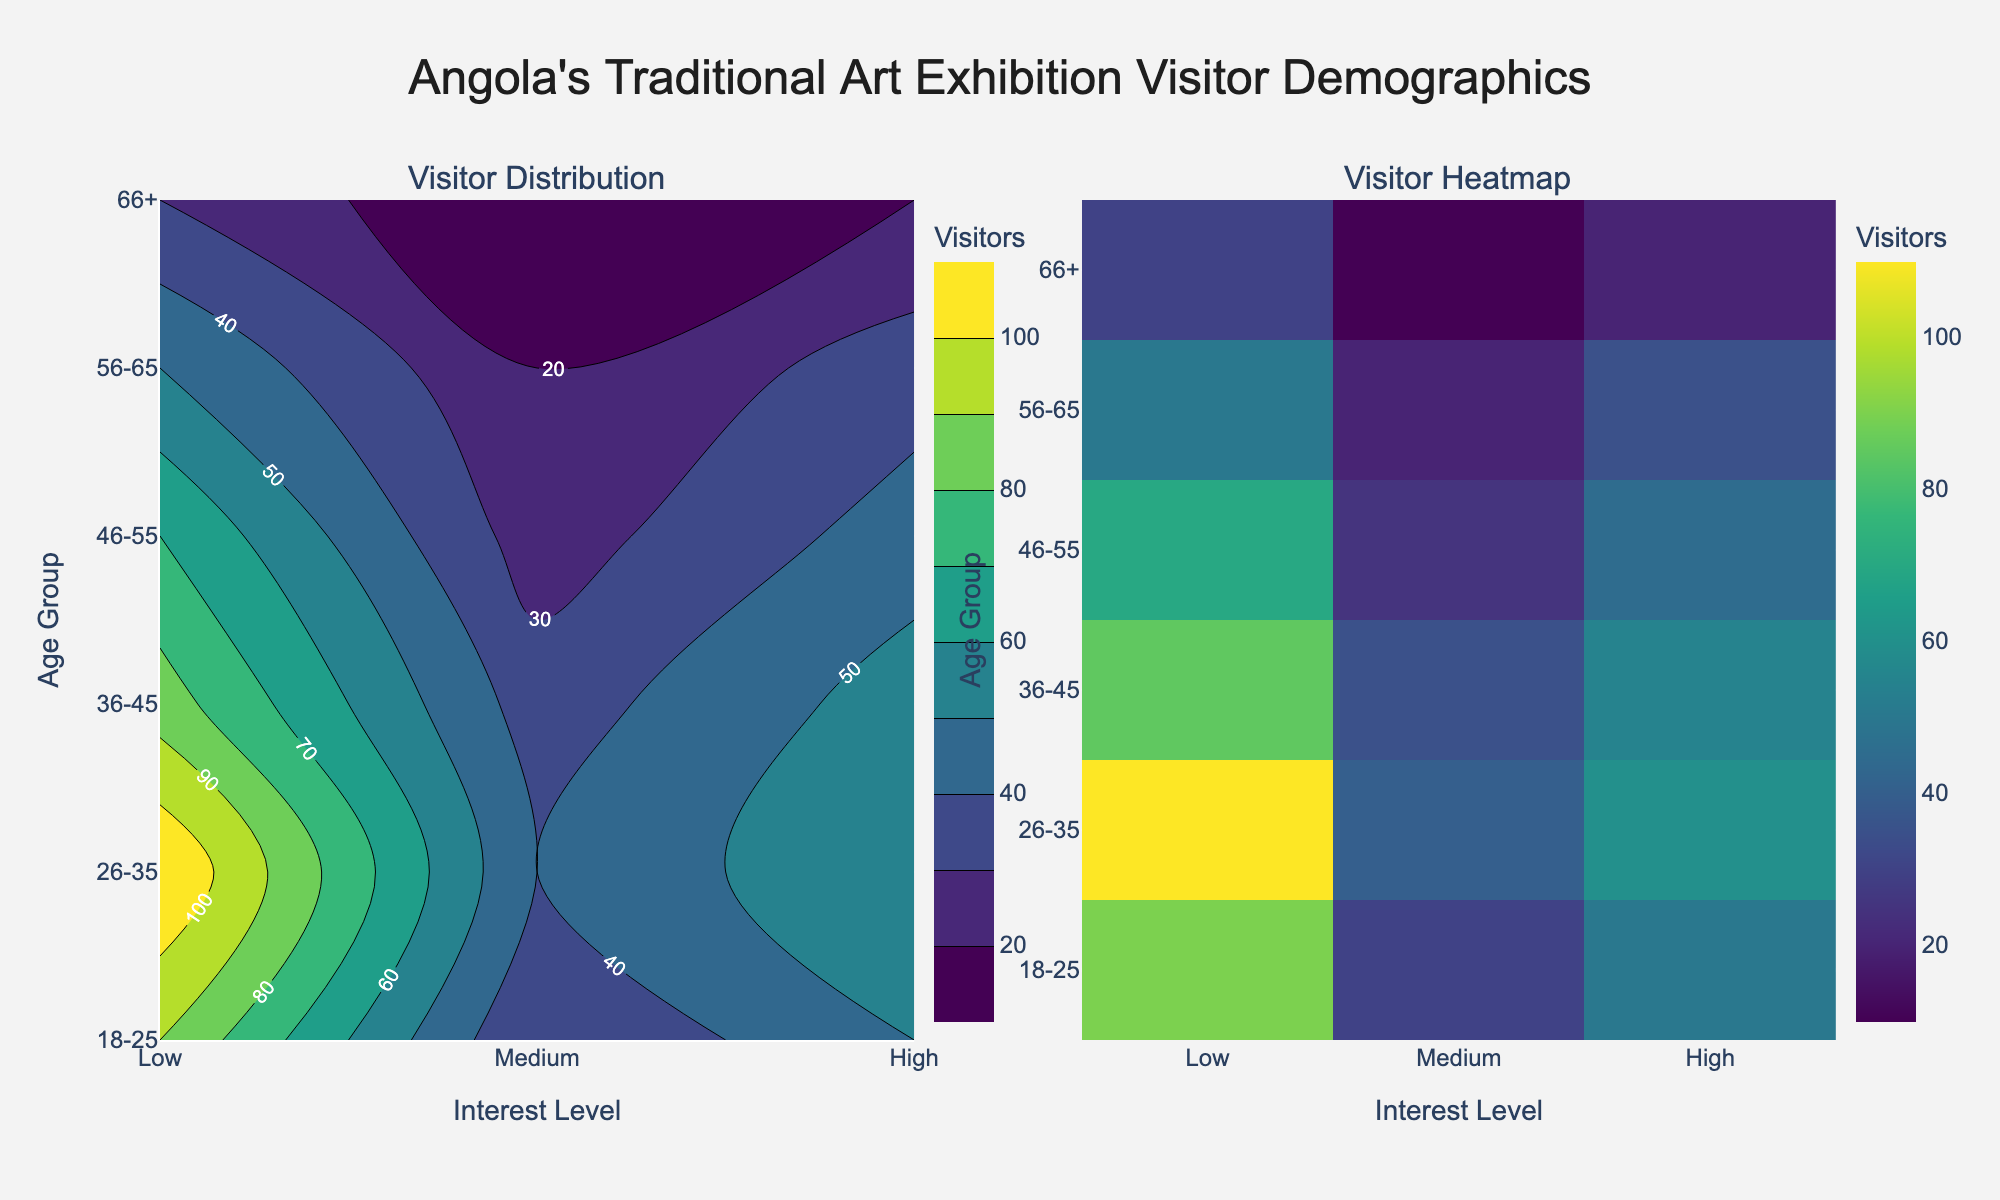What's the title of the plot? The plot title is usually located at the top center of the figure. In this case, we look at the top to find the text describing the main focus, which reads "Angola's Traditional Art Exhibition Visitor Demographics".
Answer: Angola's Traditional Art Exhibition Visitor Demographics What are the two main visualization types used in the figure? The figure is divided into two sections, each using a different type of plot. The left section is a contour plot, and the right section is a heatmap.
Answer: Contour plot and heatmap Which age group has the highest number of visitors with "High" interest? To find this, look at the intersection of the "High" interest column and the age group rows. The highest value falls under the age group 26-35 with 110 visitors.
Answer: 26-35 Which interest level has the least number of visitors in the 56-65 age group? Refer to the row corresponding to the age group 56-65 and identify the lowest value among the interest levels. The lowest value is in the "Low" interest level with 20 visitors.
Answer: Low What is the combined number of visitors in the 36-45 age group with "Medium" and "High" interest levels? Add the values for "Medium" and "High" interest levels in the 36-45 age group: 55 (Medium) + 85 (High) = 140.
Answer: 140 How does the visitor distribution change from Low to High interest levels in the age group 18-25? Observe the values changing across the "Low", "Medium", and "High" columns for the 18-25 age group: 30 (Low), 50 (Medium), 90 (High). The number increases progressively as interest level rises.
Answer: The number of visitors increases Compare the number of visitors with "Medium" interest between the age groups 26-35 and 46-55. Which age group has more visitors, and by how much? Look at the "Medium" interest column values for both age groups: 26-35 has 60 visitors and 46-55 has 45 visitors. 26-35 age group has 15 more visitors than 46-55.
Answer: 26-35 by 15 visitors What trend do you observe in visitor quantity as age increases, particularly under the "High" interest level? Check the vertical sequence of values under the "High" interest column for increasing age groups: 90 (18-25), 110 (26-35), 85 (36-45), 70 (46-55), 50 (56-65), 30 (66+). There's a peak at 26-35, and then the number of visitors gradually decreases with increasing age.
Answer: Peaks at 26-35 and then decreases Which visual representation, contour or heatmap, gives a clearer understanding of visitor clustering based on age and interest level, and why? Compare the way both subplots display the density of visitors spread. The contour plot shows lines connecting areas with the same visitor quantities, making it easier to see clusters and transitions. The heatmap uses color intensity, providing a straightforward sense of concentration but less about transitions. Contour is often better for clustering.
Answer: Contour plot, because it shows clusters and transitions more clearly How many interest levels are represented in both visualizations of the figure? Look at the x-axis, which represents different interest levels. There are three labels marking the interest levels: "Low", "Medium", "High".
Answer: Three 